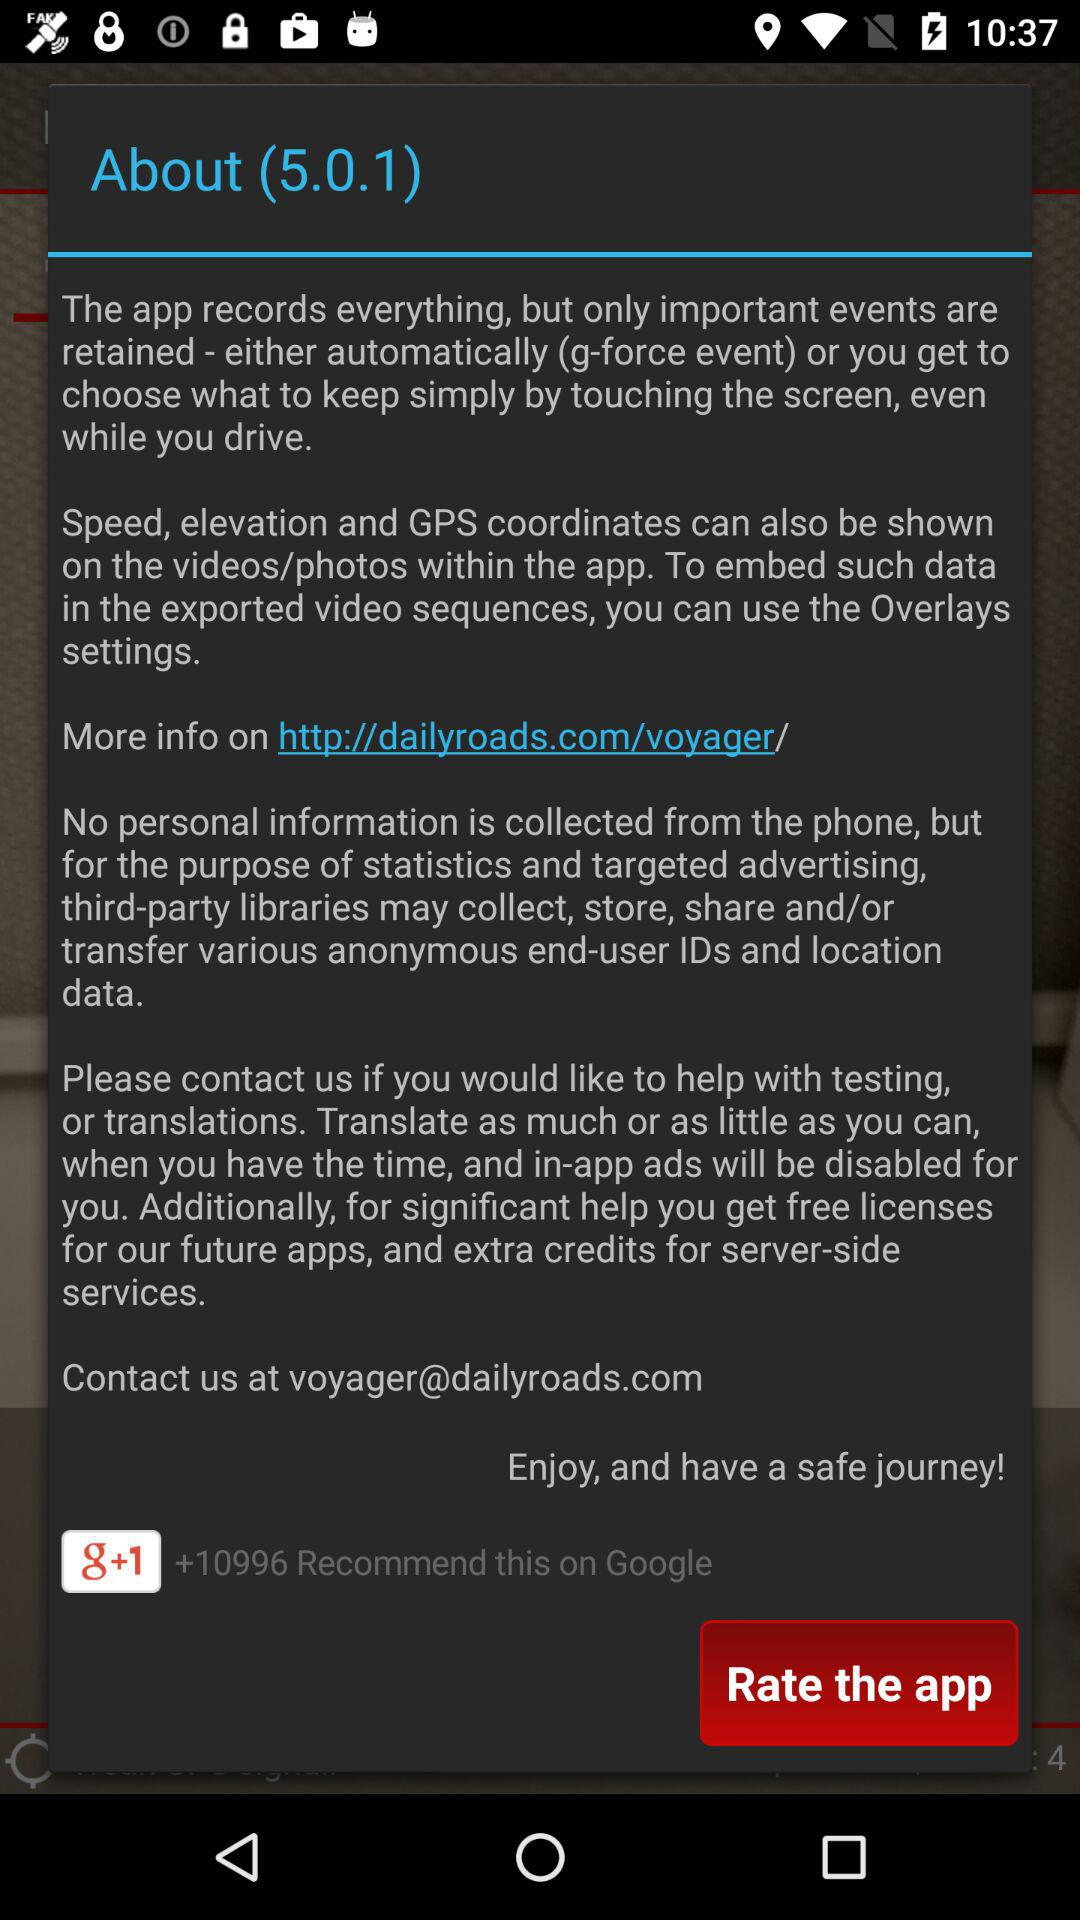What is the version of the application? The application version is 5.0.1. 